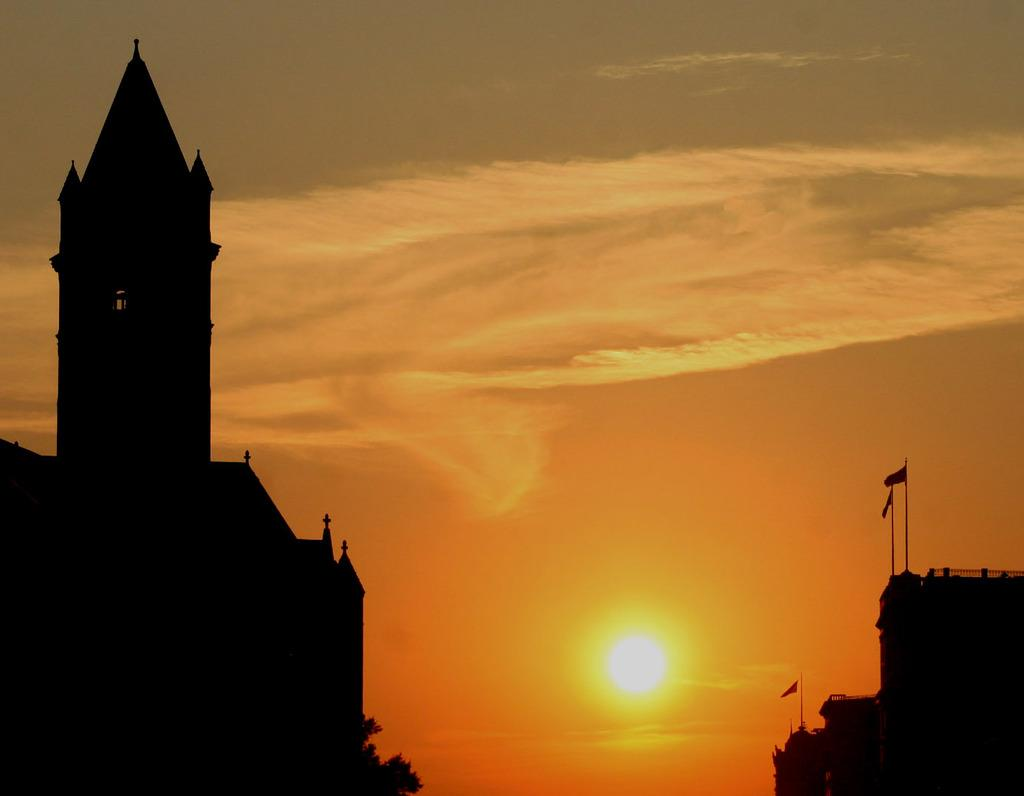What can be seen in the sky in the image? The sky is visible in the image. What is happening to the sun in the image? The sun is setting in the image. What type of structure is present in the image? There is a building in the image. How would you describe the lighting in the image? The image is dark. What type of calculator can be seen on the roof of the building in the image? There is no calculator present on the roof of the building in the image. Is there a bottle of honey visible in the image? There is no bottle of honey present in the image. 